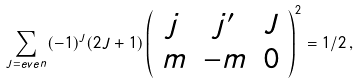<formula> <loc_0><loc_0><loc_500><loc_500>\sum _ { J = e v e n } ( - 1 ) ^ { J } ( 2 J + 1 ) \left ( \begin{array} { c c c } j & j ^ { \prime } & J \\ m & - m & 0 \\ \end{array} \right ) ^ { 2 } = 1 / 2 \, ,</formula> 